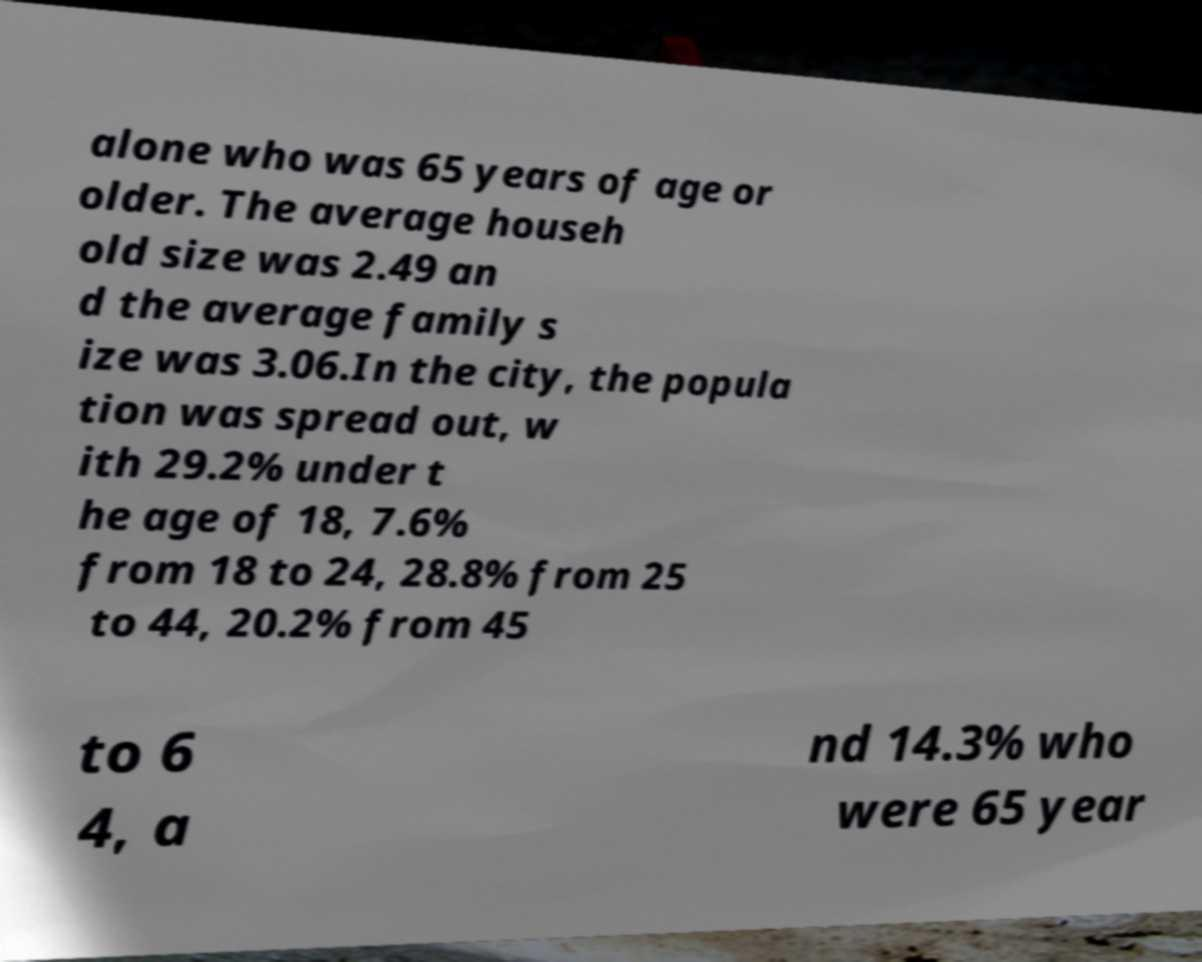Please identify and transcribe the text found in this image. alone who was 65 years of age or older. The average househ old size was 2.49 an d the average family s ize was 3.06.In the city, the popula tion was spread out, w ith 29.2% under t he age of 18, 7.6% from 18 to 24, 28.8% from 25 to 44, 20.2% from 45 to 6 4, a nd 14.3% who were 65 year 